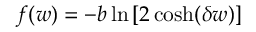<formula> <loc_0><loc_0><loc_500><loc_500>f ( w ) = - b \ln \left [ 2 \cosh ( \delta w ) \right ]</formula> 